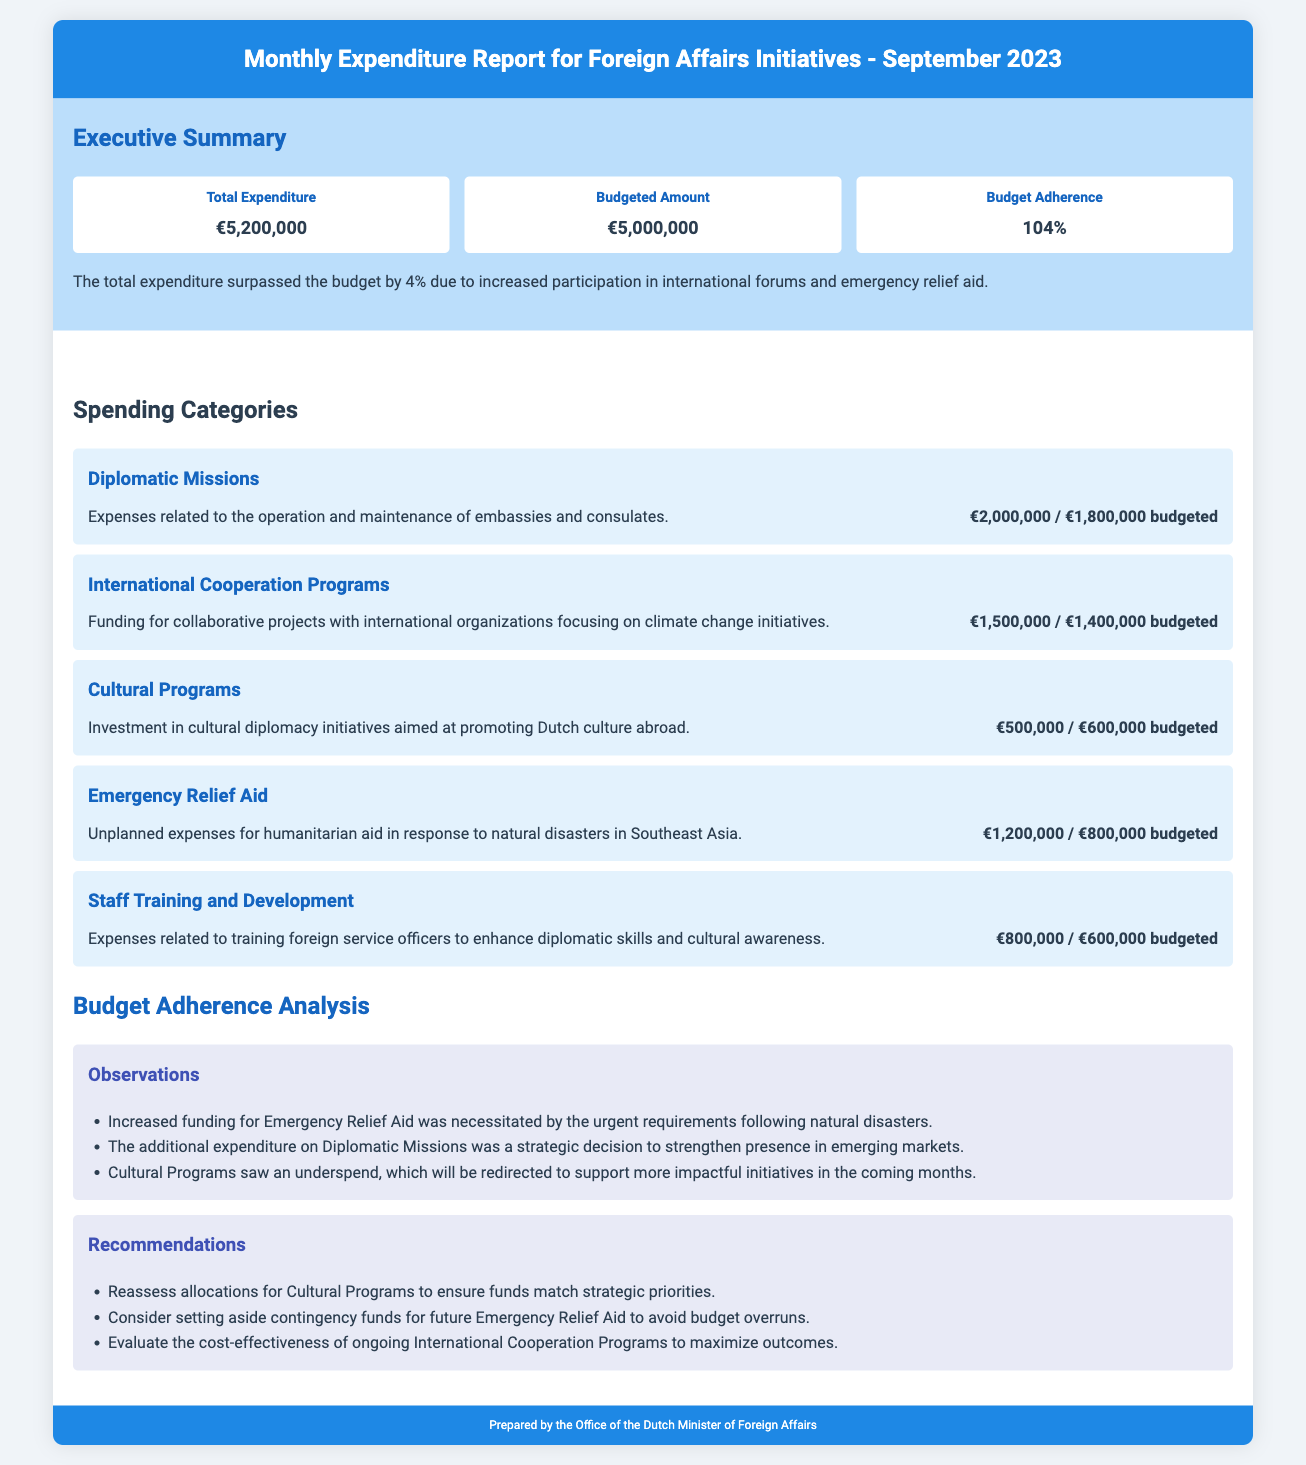What is the total expenditure? The total expenditure is stated in the executive summary of the report.
Answer: €5,200,000 What is the budgeted amount? The budgeted amount is mentioned next to the total expenditure in the executive summary.
Answer: €5,000,000 What percentage of budget adherence is indicated? The percentage of budget adherence is provided in the executive summary.
Answer: 104% How much was spent on Emergency Relief Aid? The expenditure for Emergency Relief Aid is detailed in the spending categories section of the report.
Answer: €1,200,000 What was the budgeted amount for Cultural Programs? The budgeted amount is included in the spending categories section next to the expenditure for Cultural Programs.
Answer: €600,000 What are the additional expenditures under Diplomatic Missions? The additional expenditures are derived from the difference between actual spending and budgeted amount stated in the spending categories.
Answer: €200,000 What is the recommendation for Cultural Programs? The recommendations for Cultural Programs are found in the budget adherence analysis section of the report.
Answer: Reassess allocations What necessitated the increased funding for Emergency Relief Aid? The reason for increased funding is stated in the observations section of the budget adherence analysis.
Answer: Urgent requirements following natural disasters How much was spent on Staff Training and Development? The spending for Staff Training and Development is listed under the spending categories.
Answer: €800,000 